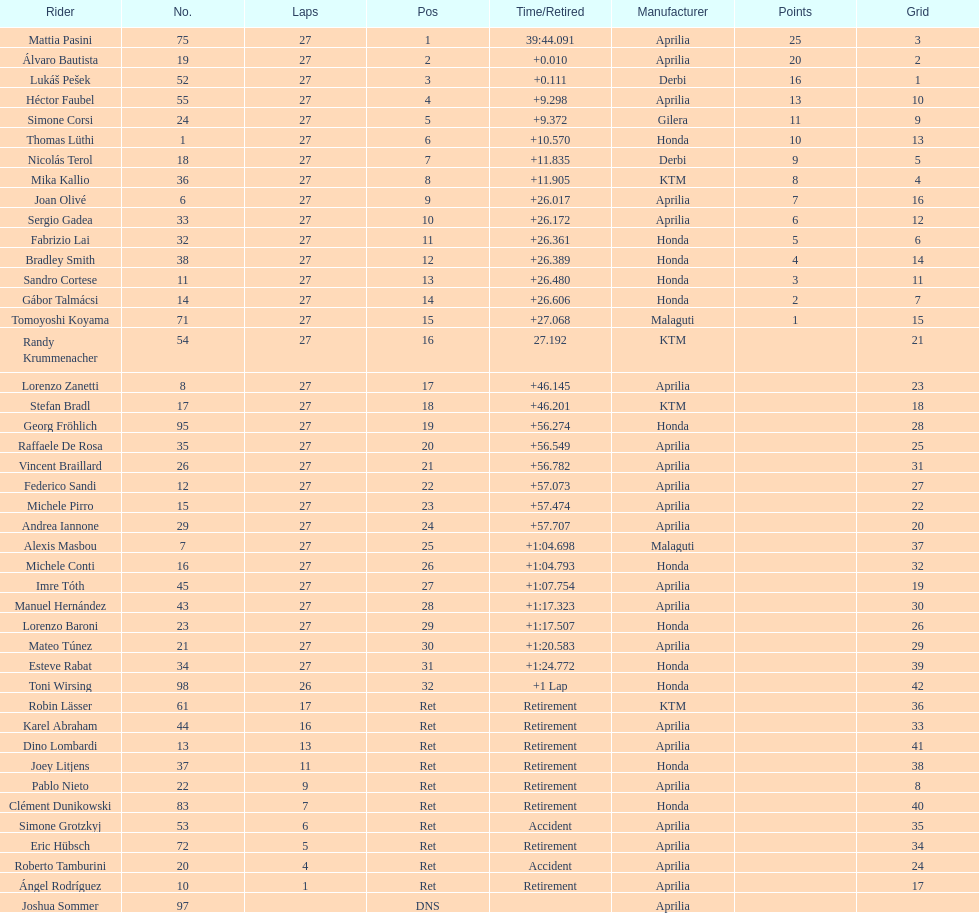How many german racers finished the race? 4. 